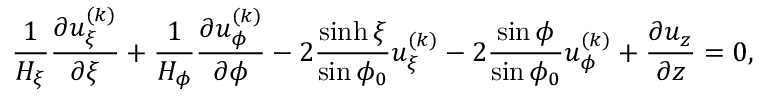<formula> <loc_0><loc_0><loc_500><loc_500>\frac { 1 } { H _ { \xi } } \frac { \partial u _ { \xi } ^ { ( k ) } } { \partial \xi } + \frac { 1 } { H _ { \phi } } \frac { \partial u _ { \phi } ^ { ( k ) } } { \partial \phi } - 2 \frac { \sinh \xi } { \sin \phi _ { 0 } } u _ { \xi } ^ { ( k ) } - 2 \frac { \sin \phi } { \sin \phi _ { 0 } } u _ { \phi } ^ { ( k ) } + \frac { \partial u _ { z } } { \partial z } = 0 ,</formula> 